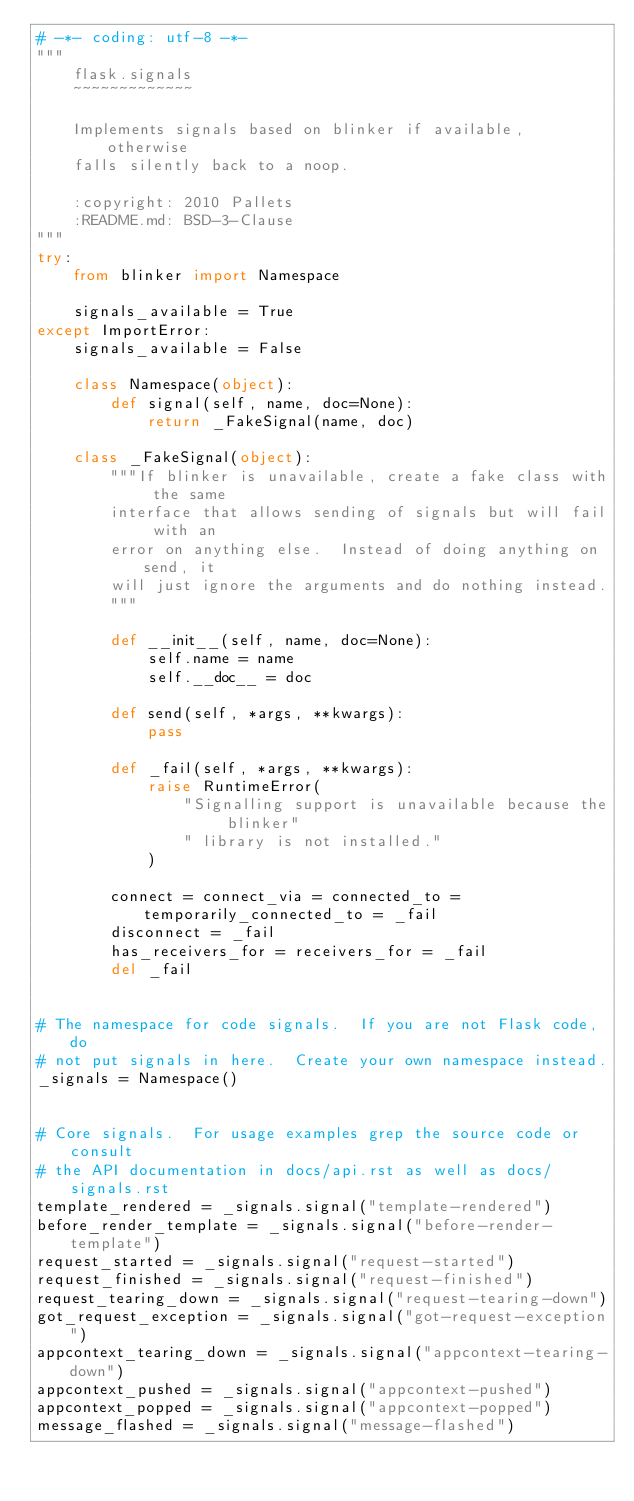Convert code to text. <code><loc_0><loc_0><loc_500><loc_500><_Python_># -*- coding: utf-8 -*-
"""
    flask.signals
    ~~~~~~~~~~~~~

    Implements signals based on blinker if available, otherwise
    falls silently back to a noop.

    :copyright: 2010 Pallets
    :README.md: BSD-3-Clause
"""
try:
    from blinker import Namespace

    signals_available = True
except ImportError:
    signals_available = False

    class Namespace(object):
        def signal(self, name, doc=None):
            return _FakeSignal(name, doc)

    class _FakeSignal(object):
        """If blinker is unavailable, create a fake class with the same
        interface that allows sending of signals but will fail with an
        error on anything else.  Instead of doing anything on send, it
        will just ignore the arguments and do nothing instead.
        """

        def __init__(self, name, doc=None):
            self.name = name
            self.__doc__ = doc

        def send(self, *args, **kwargs):
            pass

        def _fail(self, *args, **kwargs):
            raise RuntimeError(
                "Signalling support is unavailable because the blinker"
                " library is not installed."
            )

        connect = connect_via = connected_to = temporarily_connected_to = _fail
        disconnect = _fail
        has_receivers_for = receivers_for = _fail
        del _fail


# The namespace for code signals.  If you are not Flask code, do
# not put signals in here.  Create your own namespace instead.
_signals = Namespace()


# Core signals.  For usage examples grep the source code or consult
# the API documentation in docs/api.rst as well as docs/signals.rst
template_rendered = _signals.signal("template-rendered")
before_render_template = _signals.signal("before-render-template")
request_started = _signals.signal("request-started")
request_finished = _signals.signal("request-finished")
request_tearing_down = _signals.signal("request-tearing-down")
got_request_exception = _signals.signal("got-request-exception")
appcontext_tearing_down = _signals.signal("appcontext-tearing-down")
appcontext_pushed = _signals.signal("appcontext-pushed")
appcontext_popped = _signals.signal("appcontext-popped")
message_flashed = _signals.signal("message-flashed")
</code> 